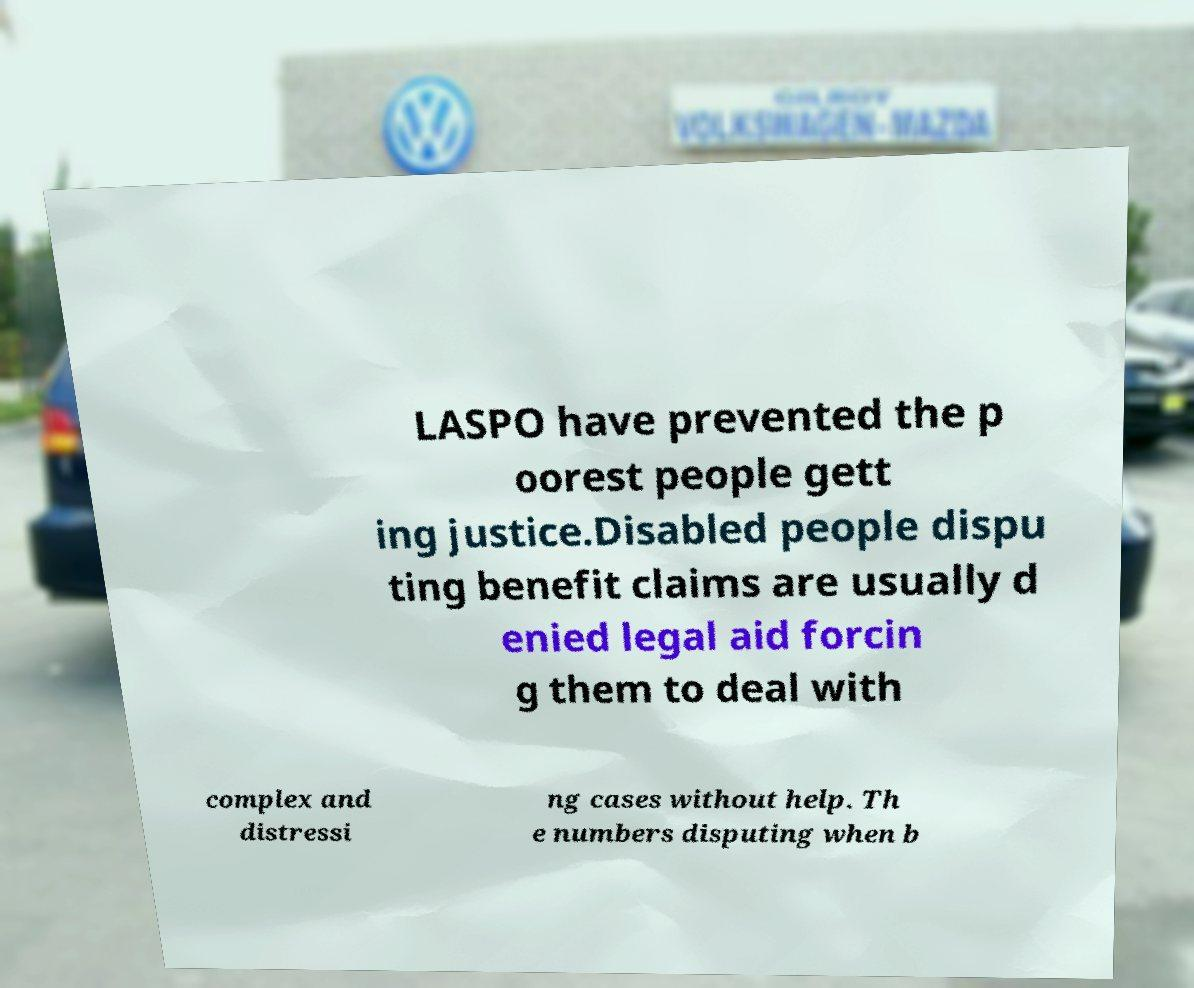Could you assist in decoding the text presented in this image and type it out clearly? LASPO have prevented the p oorest people gett ing justice.Disabled people dispu ting benefit claims are usually d enied legal aid forcin g them to deal with complex and distressi ng cases without help. Th e numbers disputing when b 